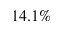<formula> <loc_0><loc_0><loc_500><loc_500>1 4 . 1 \%</formula> 